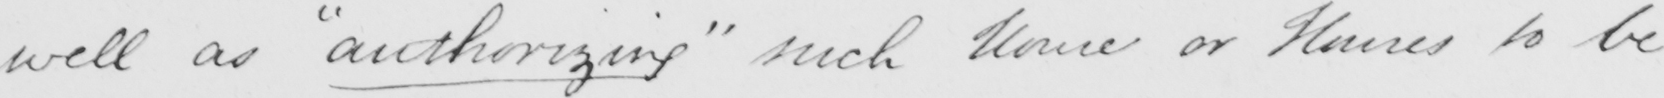What is written in this line of handwriting? well as  " authorizing "  such House or Houses to be 